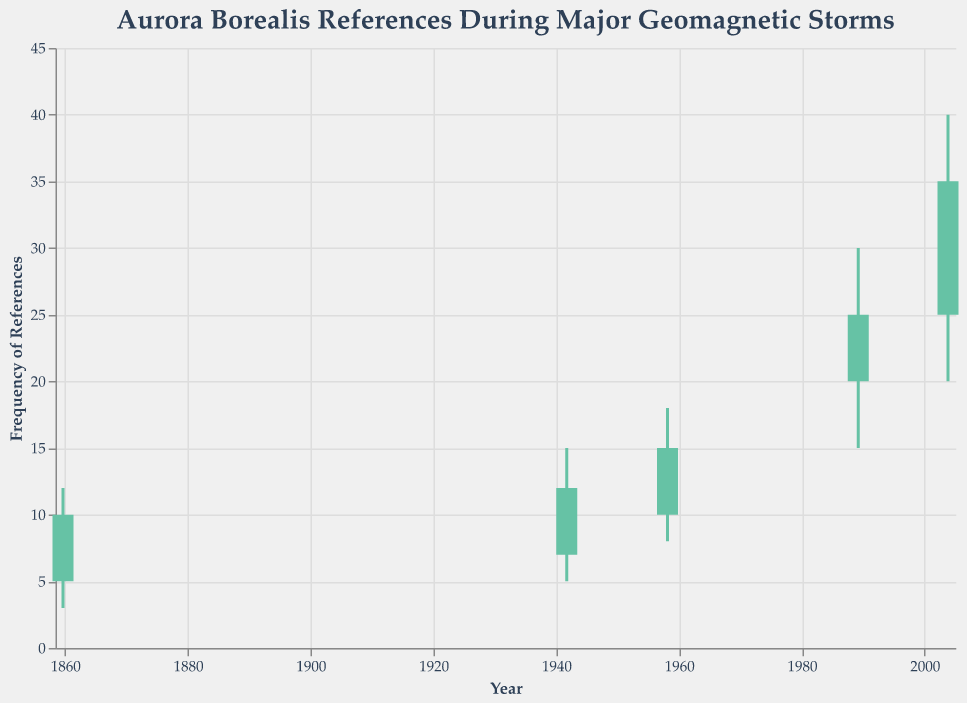What's the title of the figure? The title is displayed at the top of the figure. It reads "Aurora Borealis References During Major Geomagnetic Storms".
Answer: Aurora Borealis References During Major Geomagnetic Storms What does the x-axis represent? The x-axis represents the date of the geomagnetic storms. It is labeled with "Year" and formatted in yearly intervals.
Answer: Date of the storms (Year) How many data points are represented in the figure? The data points are represented by 5 candlesticks, each corresponding to a specific date of a geomagnetic storm.
Answer: 5 Which date has the highest recorded frequency of references to the Aurora Borealis? The high value of each candlestick represents the peak frequency. The highest recorded value is 40 on October 28, 2003.
Answer: October 28, 2003 What is the frequency range (difference between the highest and lowest points) on March 13, 1989? The frequency range for March 13, 1989, is determined by subtracting the low value from the high value. The high is 30 and the low is 15, so the range is 30 - 15.
Answer: 15 On which dates did the frequency of references end higher than it started? The closing value must be higher than the opening value. This happened on September 1, 1859, September 18, 1941, February 11, 1958, and October 28, 2003.
Answer: September 1, 1859; September 18, 1941; February 11, 1958; October 28, 2003 What is the average closing frequency of all data points? The closing values are 10, 12, 15, 25, and 35. Summing them gives 97, and dividing by 5 gives an average of 97 / 5.
Answer: 19.4 How does the closing frequency of references on October 28, 2003, compare to that on March 13, 1989? The closing value on October 28, 2003, is 35 and on March 13, 1989, is 25. 35 is higher than 25.
Answer: October 28, 2003, had a higher closing frequency Which date showed the greatest increase in the frequency of references during the storm? The increase is calculated by subtracting the open value from the close value. The largest increase occurred on October 28, 2003, where the close is 35 and the open is 25, resulting in an increase of 35 - 25.
Answer: October 28, 2003 What is the median opening frequency across all dates? The opening values are 5, 7, 10, 20, and 25. Ordering them and finding the middle value gives 10.
Answer: 10 